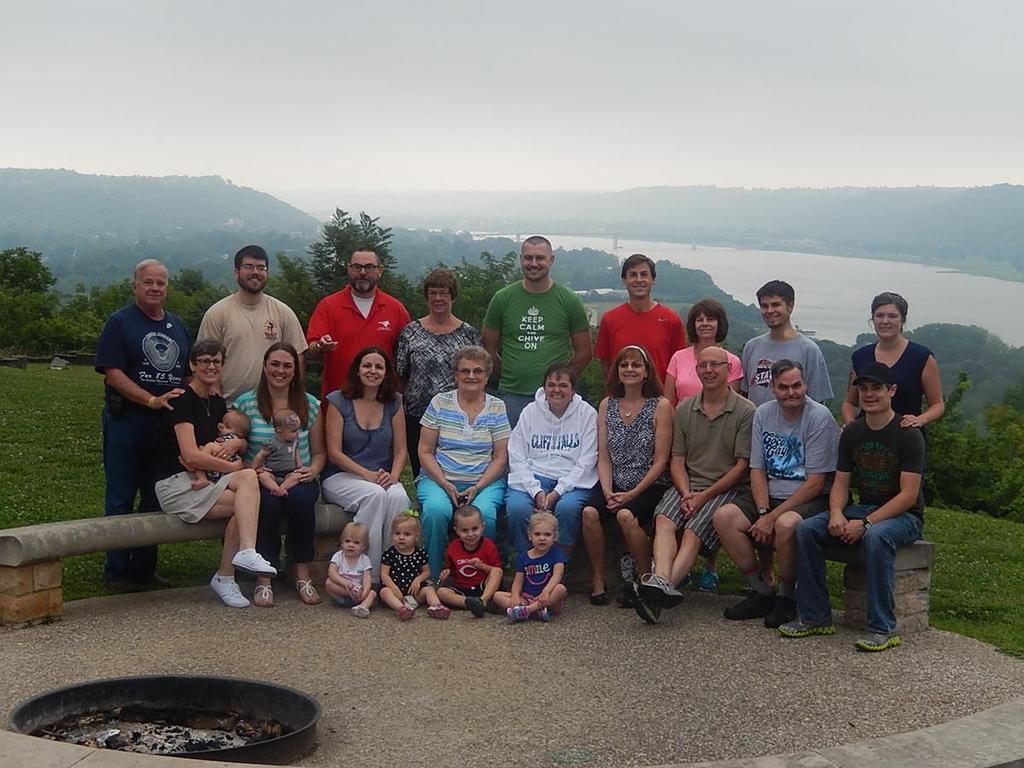Can you describe this image briefly? In this picture there are four children who are sitting on the ground. Behind them there is a group of persons who are sitting on the bench. Behind them there is another group were standing on the ground. In the background i can see trees, plants, grass, building, mountain and river. At the top i can see the sky and clouds. At the bottom left corner there is a steel object. 